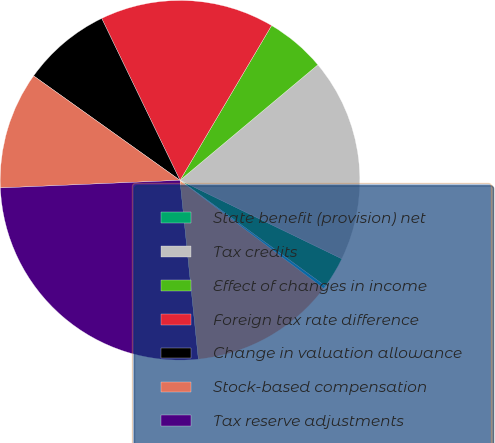Convert chart to OTSL. <chart><loc_0><loc_0><loc_500><loc_500><pie_chart><fcel>State benefit (provision) net<fcel>Tax credits<fcel>Effect of changes in income<fcel>Foreign tax rate difference<fcel>Change in valuation allowance<fcel>Stock-based compensation<fcel>Tax reserve adjustments<fcel>Deemed dividend<fcel>Other income tax (expense)<nl><fcel>2.83%<fcel>18.29%<fcel>5.4%<fcel>15.68%<fcel>7.97%<fcel>10.54%<fcel>25.96%<fcel>13.11%<fcel>0.25%<nl></chart> 